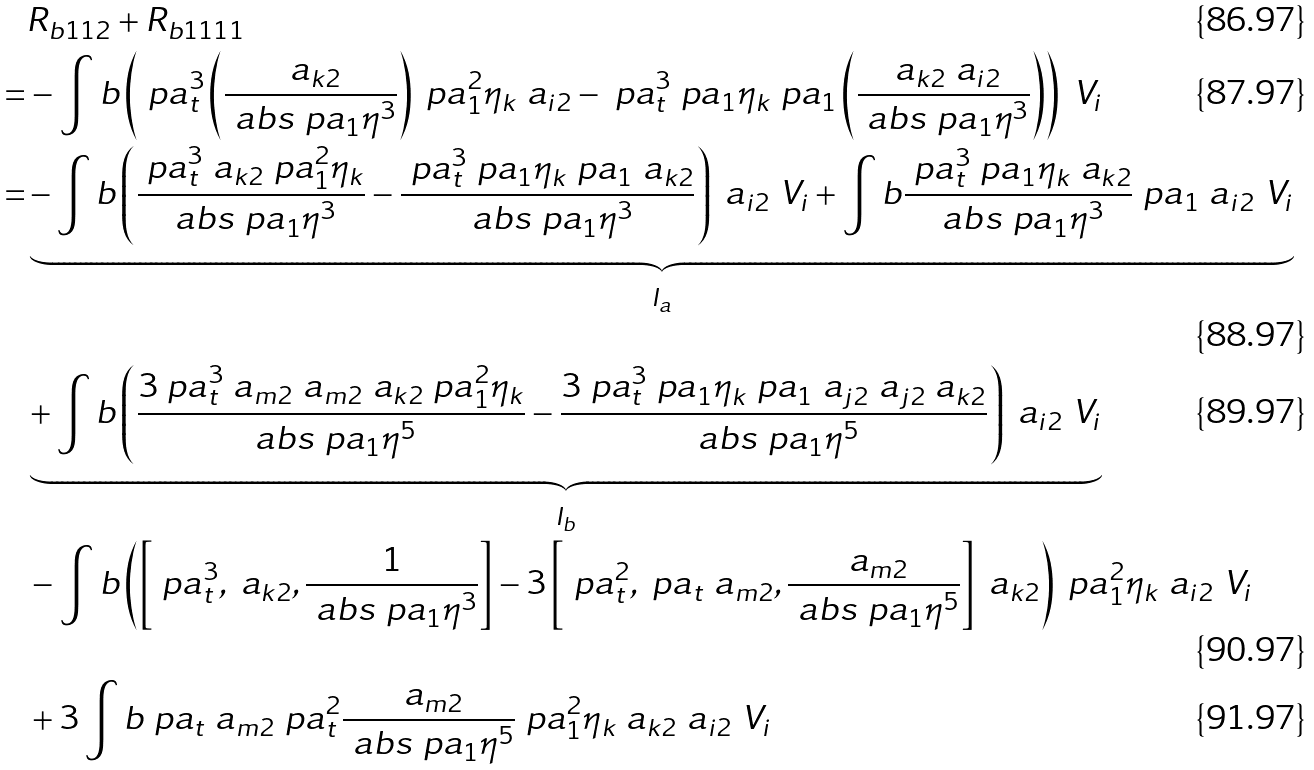<formula> <loc_0><loc_0><loc_500><loc_500>& R _ { b 1 1 2 } + R _ { b 1 1 1 1 } \\ = & - \int b \left ( \ p a _ { t } ^ { 3 } \left ( \frac { \ a _ { k 2 } } { \ a b s { \ p a _ { 1 } \eta } ^ { 3 } } \right ) \ p a _ { 1 } ^ { 2 } \eta _ { k } \ a _ { i 2 } - \ p a _ { t } ^ { 3 } \ p a _ { 1 } \eta _ { k } \ p a _ { 1 } \left ( \frac { \ a _ { k 2 } \ a _ { i 2 } } { \ a b s { \ p a _ { 1 } \eta } ^ { 3 } } \right ) \right ) \ V _ { i } \\ = & \underbrace { - \int b \left ( \frac { \ p a _ { t } ^ { 3 } \ a _ { k 2 } \ p a _ { 1 } ^ { 2 } \eta _ { k } } { \ a b s { \ p a _ { 1 } \eta } ^ { 3 } } - \frac { \ p a _ { t } ^ { 3 } \ p a _ { 1 } \eta _ { k } \ p a _ { 1 } \ a _ { k 2 } } { \ a b s { \ p a _ { 1 } \eta } ^ { 3 } } \right ) \ a _ { i 2 } \ V _ { i } + \int b \frac { \ p a _ { t } ^ { 3 } \ p a _ { 1 } \eta _ { k } \ a _ { k 2 } } { \ a b s { \ p a _ { 1 } \eta } ^ { 3 } } \ p a _ { 1 } \ a _ { i 2 } \ V _ { i } } _ { I _ { a } } \\ & \underbrace { + \int b \left ( \frac { 3 \ p a _ { t } ^ { 3 } \ a _ { m 2 } \ a _ { m 2 } \ a _ { k 2 } \ p a _ { 1 } ^ { 2 } \eta _ { k } } { \ a b s { \ p a _ { 1 } \eta } ^ { 5 } } - \frac { 3 \ p a _ { t } ^ { 3 } \ p a _ { 1 } \eta _ { k } \ p a _ { 1 } \ a _ { j 2 } \ a _ { j 2 } \ a _ { k 2 } } { \ a b s { \ p a _ { 1 } \eta } ^ { 5 } } \right ) \ a _ { i 2 } \ V _ { i } } _ { I _ { b } } \\ & - \int b \left ( \left [ \ p a _ { t } ^ { 3 } , \ a _ { k 2 } , \frac { 1 } { \ a b s { \ p a _ { 1 } \eta } ^ { 3 } } \right ] - 3 \left [ \ p a _ { t } ^ { 2 } , \ p a _ { t } \ a _ { m 2 } , \frac { \ a _ { m 2 } } { \ a b s { \ p a _ { 1 } \eta } ^ { 5 } } \right ] \ a _ { k 2 } \right ) \ p a _ { 1 } ^ { 2 } \eta _ { k } \ a _ { i 2 } \ V _ { i } \\ & + 3 \int b \ p a _ { t } \ a _ { m 2 } \ p a _ { t } ^ { 2 } \frac { \ a _ { m 2 } } { \ a b s { \ p a _ { 1 } \eta } ^ { 5 } } \ p a _ { 1 } ^ { 2 } \eta _ { k } \ a _ { k 2 } \ a _ { i 2 } \ V _ { i }</formula> 